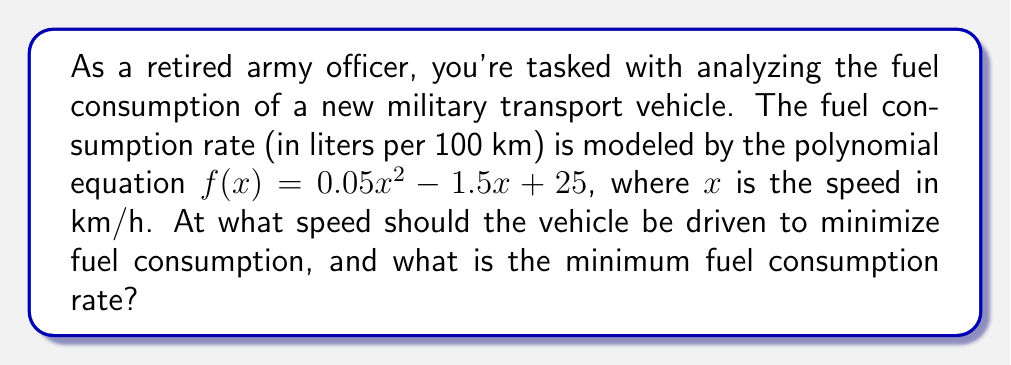Can you solve this math problem? To find the speed that minimizes fuel consumption and the minimum fuel consumption rate, we need to follow these steps:

1. The function $f(x) = 0.05x^2 - 1.5x + 25$ is a quadratic equation, and its graph is a parabola that opens upward (since the coefficient of $x^2$ is positive).

2. The minimum point of a parabola occurs at the vertex. To find the vertex, we can use the formula $x = -\frac{b}{2a}$, where $a$ and $b$ are the coefficients of $x^2$ and $x$ respectively.

3. In this case, $a = 0.05$ and $b = -1.5$. Let's calculate the x-coordinate of the vertex:

   $x = -\frac{b}{2a} = -\frac{-1.5}{2(0.05)} = \frac{1.5}{0.1} = 15$

4. The speed that minimizes fuel consumption is 15 km/h.

5. To find the minimum fuel consumption rate, we need to calculate $f(15)$:

   $f(15) = 0.05(15)^2 - 1.5(15) + 25$
   $= 0.05(225) - 22.5 + 25$
   $= 11.25 - 22.5 + 25$
   $= 13.75$

Therefore, the minimum fuel consumption rate is 13.75 liters per 100 km.
Answer: 15 km/h; 13.75 L/100km 